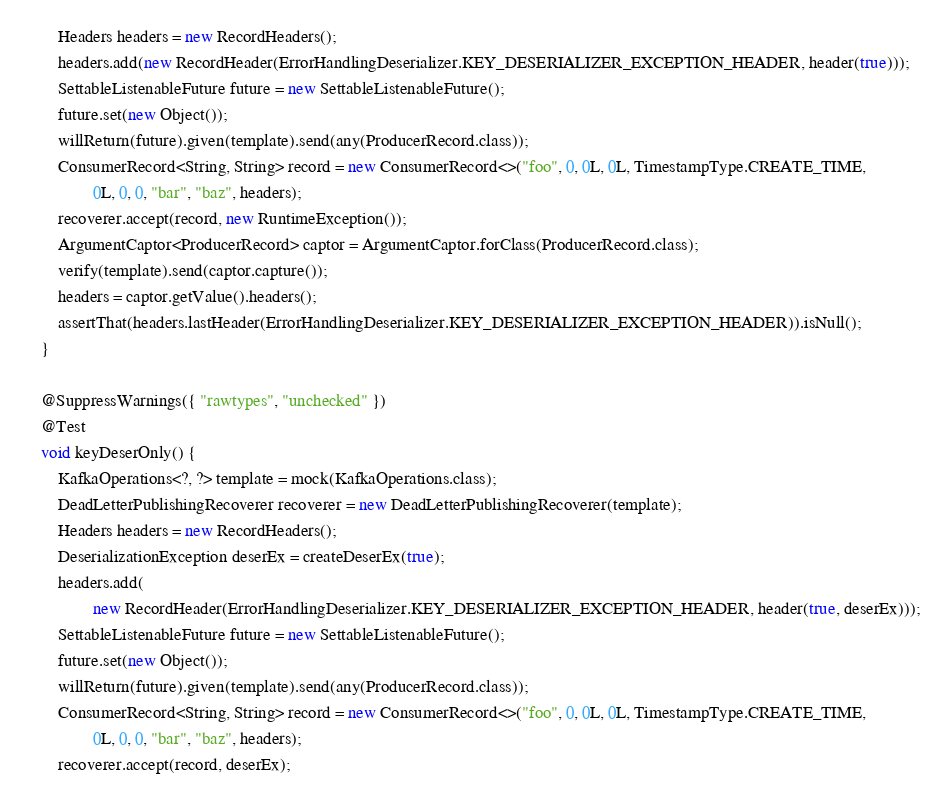<code> <loc_0><loc_0><loc_500><loc_500><_Java_>		Headers headers = new RecordHeaders();
		headers.add(new RecordHeader(ErrorHandlingDeserializer.KEY_DESERIALIZER_EXCEPTION_HEADER, header(true)));
		SettableListenableFuture future = new SettableListenableFuture();
		future.set(new Object());
		willReturn(future).given(template).send(any(ProducerRecord.class));
		ConsumerRecord<String, String> record = new ConsumerRecord<>("foo", 0, 0L, 0L, TimestampType.CREATE_TIME,
				0L, 0, 0, "bar", "baz", headers);
		recoverer.accept(record, new RuntimeException());
		ArgumentCaptor<ProducerRecord> captor = ArgumentCaptor.forClass(ProducerRecord.class);
		verify(template).send(captor.capture());
		headers = captor.getValue().headers();
		assertThat(headers.lastHeader(ErrorHandlingDeserializer.KEY_DESERIALIZER_EXCEPTION_HEADER)).isNull();
	}

	@SuppressWarnings({ "rawtypes", "unchecked" })
	@Test
	void keyDeserOnly() {
		KafkaOperations<?, ?> template = mock(KafkaOperations.class);
		DeadLetterPublishingRecoverer recoverer = new DeadLetterPublishingRecoverer(template);
		Headers headers = new RecordHeaders();
		DeserializationException deserEx = createDeserEx(true);
		headers.add(
				new RecordHeader(ErrorHandlingDeserializer.KEY_DESERIALIZER_EXCEPTION_HEADER, header(true, deserEx)));
		SettableListenableFuture future = new SettableListenableFuture();
		future.set(new Object());
		willReturn(future).given(template).send(any(ProducerRecord.class));
		ConsumerRecord<String, String> record = new ConsumerRecord<>("foo", 0, 0L, 0L, TimestampType.CREATE_TIME,
				0L, 0, 0, "bar", "baz", headers);
		recoverer.accept(record, deserEx);</code> 